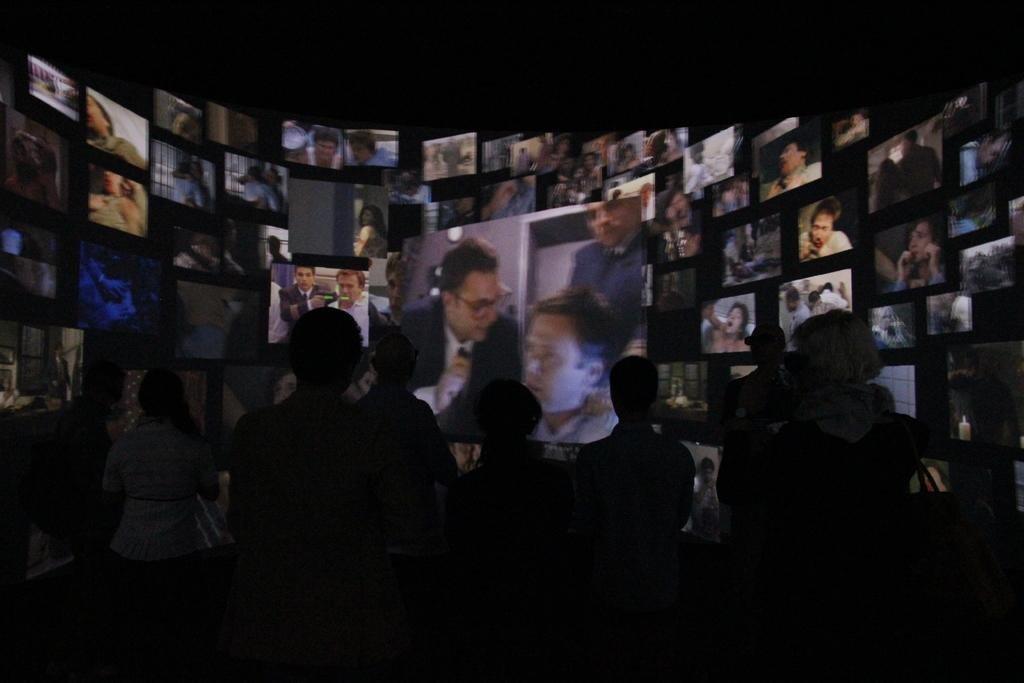What is present on the wall in the image? There are screens on the wall in the image. What can be observed in front of the screens? There are shadows of people in front of the screens. What type of pencil is the boy using to draw on the screens in the image? There is no boy or pencil present in the image; it only features shadows of people in front of the screens. 